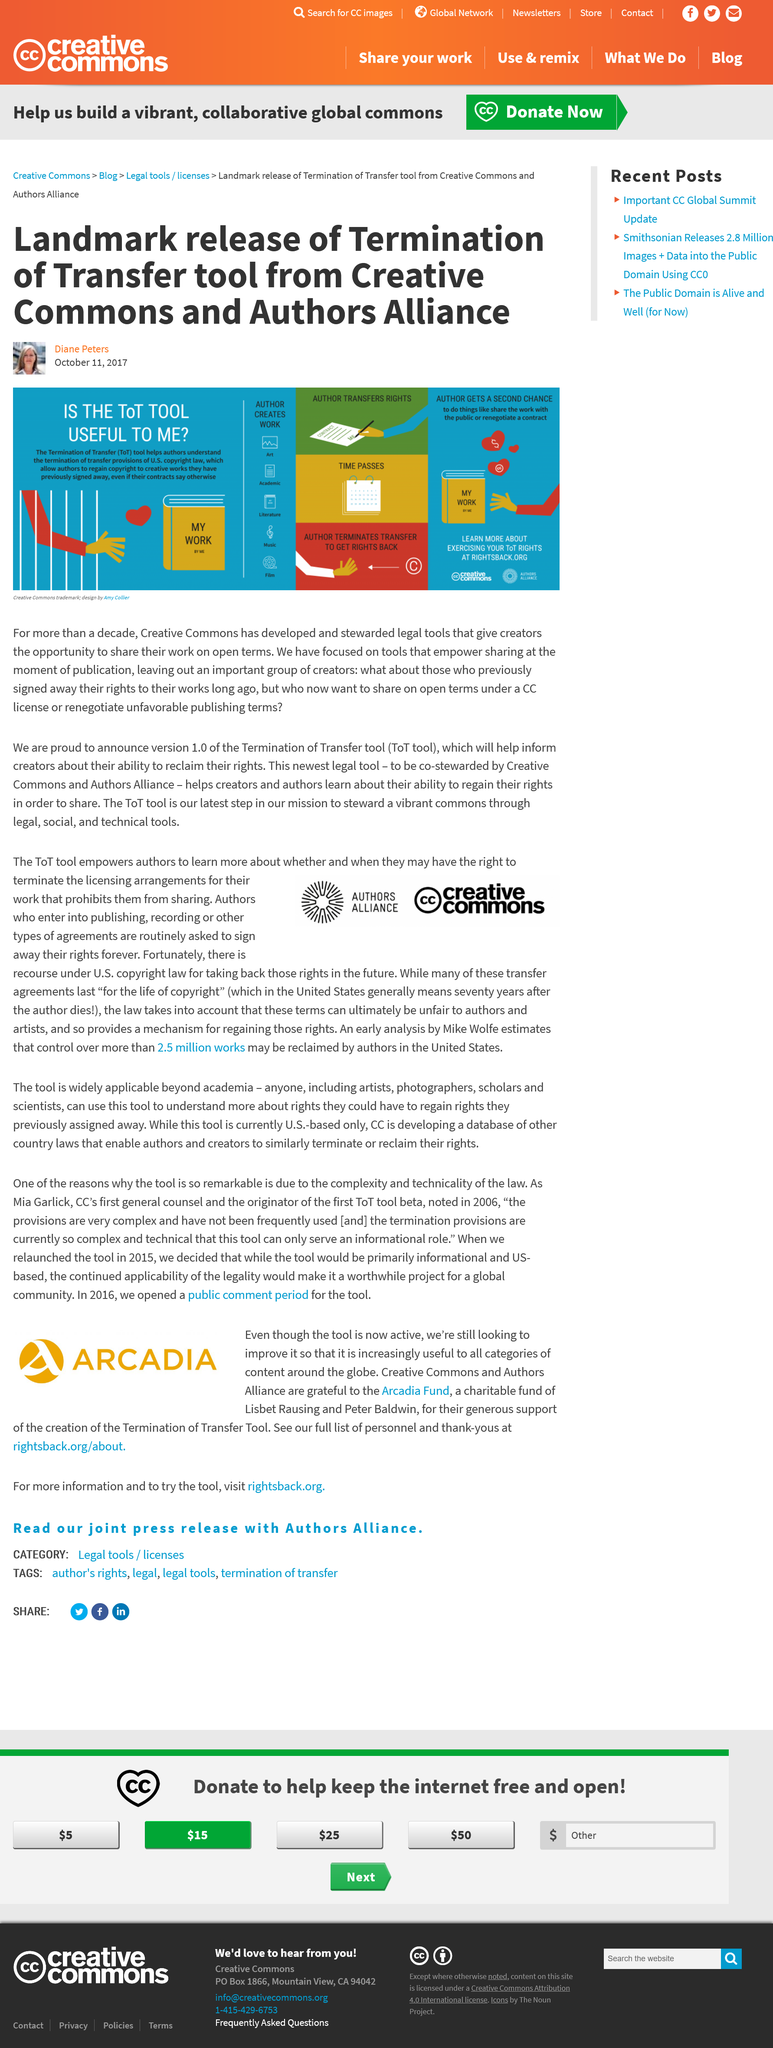Specify some key components in this picture. Copyright in the United States lasts for 70 years after the author's death. The ToT tool enables authors to reclaim ownership of their work. The Creative Commons and authors alliance released the termination of transfer tool. The image on this website has a trademark that belongs to Creative Commons. Under certain circumstances, an author may have the ability to change the license of their work. This may involve transferring their rights or negotiating a new contract in order to make their work available to the public again. 